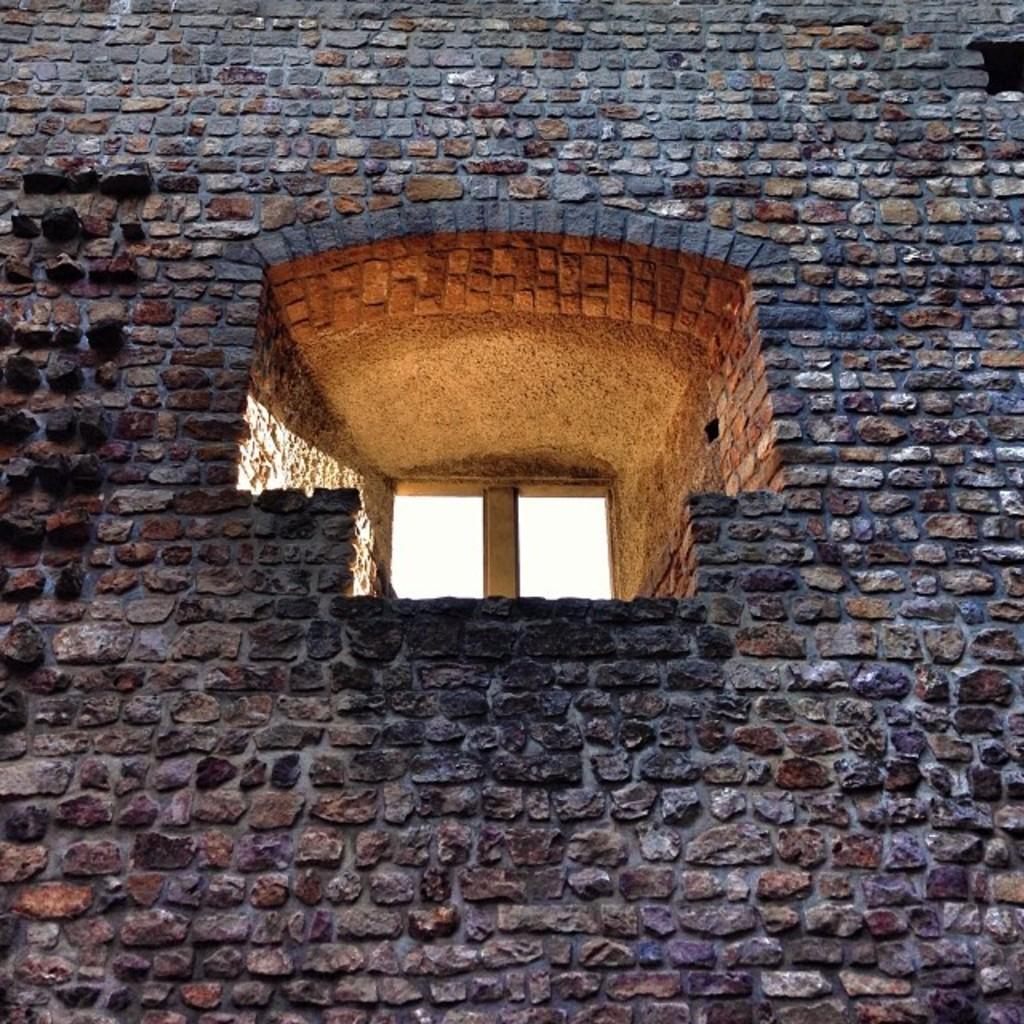Can you describe this image briefly? In this image in the center there is one window and wall. 